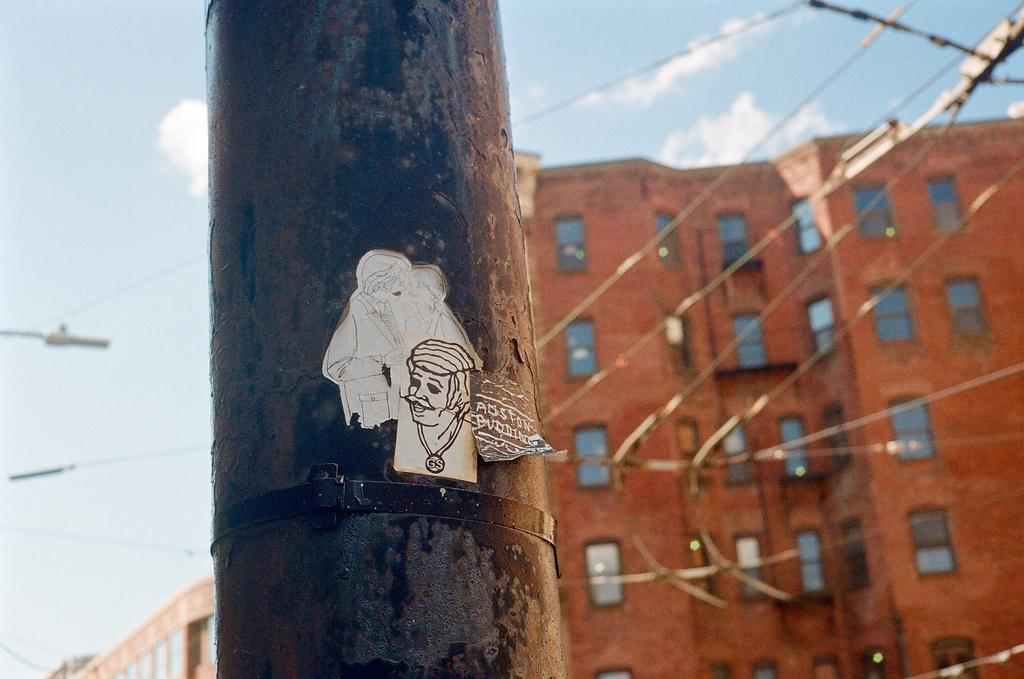What is the main object in the image? There is a pole in the image. What can be seen in the background of the image? There are buildings and the sky visible in the background of the image. What is the condition of the sky in the image? Clouds are present in the sky in the image. What type of ice can be seen melting on the head of the person in the image? There is no person or ice present in the image; it only features a pole and the background. 